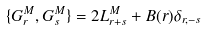<formula> <loc_0><loc_0><loc_500><loc_500>\{ G ^ { M } _ { r } , G ^ { M } _ { s } \} = 2 L _ { r + s } ^ { M } + B ( r ) \delta _ { r , - s }</formula> 